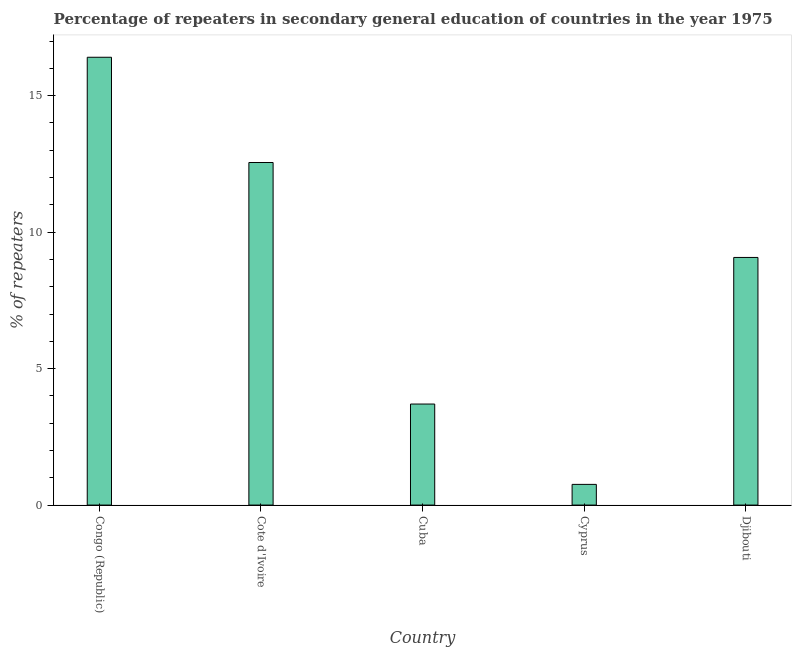Does the graph contain any zero values?
Keep it short and to the point. No. What is the title of the graph?
Offer a very short reply. Percentage of repeaters in secondary general education of countries in the year 1975. What is the label or title of the X-axis?
Your answer should be compact. Country. What is the label or title of the Y-axis?
Provide a succinct answer. % of repeaters. What is the percentage of repeaters in Cote d'Ivoire?
Provide a short and direct response. 12.55. Across all countries, what is the maximum percentage of repeaters?
Offer a terse response. 16.41. Across all countries, what is the minimum percentage of repeaters?
Make the answer very short. 0.76. In which country was the percentage of repeaters maximum?
Provide a succinct answer. Congo (Republic). In which country was the percentage of repeaters minimum?
Your answer should be compact. Cyprus. What is the sum of the percentage of repeaters?
Your response must be concise. 42.49. What is the difference between the percentage of repeaters in Cote d'Ivoire and Djibouti?
Make the answer very short. 3.48. What is the average percentage of repeaters per country?
Make the answer very short. 8.5. What is the median percentage of repeaters?
Your answer should be compact. 9.07. In how many countries, is the percentage of repeaters greater than 12 %?
Your response must be concise. 2. What is the ratio of the percentage of repeaters in Cyprus to that in Djibouti?
Provide a succinct answer. 0.08. Is the percentage of repeaters in Cuba less than that in Cyprus?
Ensure brevity in your answer.  No. What is the difference between the highest and the second highest percentage of repeaters?
Your answer should be very brief. 3.86. Is the sum of the percentage of repeaters in Cyprus and Djibouti greater than the maximum percentage of repeaters across all countries?
Ensure brevity in your answer.  No. What is the difference between the highest and the lowest percentage of repeaters?
Your answer should be compact. 15.65. Are all the bars in the graph horizontal?
Your response must be concise. No. What is the difference between two consecutive major ticks on the Y-axis?
Offer a terse response. 5. What is the % of repeaters in Congo (Republic)?
Offer a very short reply. 16.41. What is the % of repeaters of Cote d'Ivoire?
Give a very brief answer. 12.55. What is the % of repeaters of Cuba?
Keep it short and to the point. 3.7. What is the % of repeaters in Cyprus?
Your response must be concise. 0.76. What is the % of repeaters of Djibouti?
Your answer should be very brief. 9.07. What is the difference between the % of repeaters in Congo (Republic) and Cote d'Ivoire?
Your answer should be compact. 3.86. What is the difference between the % of repeaters in Congo (Republic) and Cuba?
Your answer should be compact. 12.71. What is the difference between the % of repeaters in Congo (Republic) and Cyprus?
Provide a succinct answer. 15.65. What is the difference between the % of repeaters in Congo (Republic) and Djibouti?
Your response must be concise. 7.33. What is the difference between the % of repeaters in Cote d'Ivoire and Cuba?
Offer a very short reply. 8.85. What is the difference between the % of repeaters in Cote d'Ivoire and Cyprus?
Provide a succinct answer. 11.79. What is the difference between the % of repeaters in Cote d'Ivoire and Djibouti?
Your answer should be very brief. 3.48. What is the difference between the % of repeaters in Cuba and Cyprus?
Your answer should be compact. 2.94. What is the difference between the % of repeaters in Cuba and Djibouti?
Offer a terse response. -5.37. What is the difference between the % of repeaters in Cyprus and Djibouti?
Offer a terse response. -8.32. What is the ratio of the % of repeaters in Congo (Republic) to that in Cote d'Ivoire?
Provide a succinct answer. 1.31. What is the ratio of the % of repeaters in Congo (Republic) to that in Cuba?
Make the answer very short. 4.43. What is the ratio of the % of repeaters in Congo (Republic) to that in Cyprus?
Provide a succinct answer. 21.65. What is the ratio of the % of repeaters in Congo (Republic) to that in Djibouti?
Provide a short and direct response. 1.81. What is the ratio of the % of repeaters in Cote d'Ivoire to that in Cuba?
Your answer should be very brief. 3.39. What is the ratio of the % of repeaters in Cote d'Ivoire to that in Cyprus?
Provide a succinct answer. 16.56. What is the ratio of the % of repeaters in Cote d'Ivoire to that in Djibouti?
Give a very brief answer. 1.38. What is the ratio of the % of repeaters in Cuba to that in Cyprus?
Your answer should be compact. 4.88. What is the ratio of the % of repeaters in Cuba to that in Djibouti?
Offer a terse response. 0.41. What is the ratio of the % of repeaters in Cyprus to that in Djibouti?
Offer a very short reply. 0.08. 